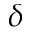Convert formula to latex. <formula><loc_0><loc_0><loc_500><loc_500>\delta</formula> 